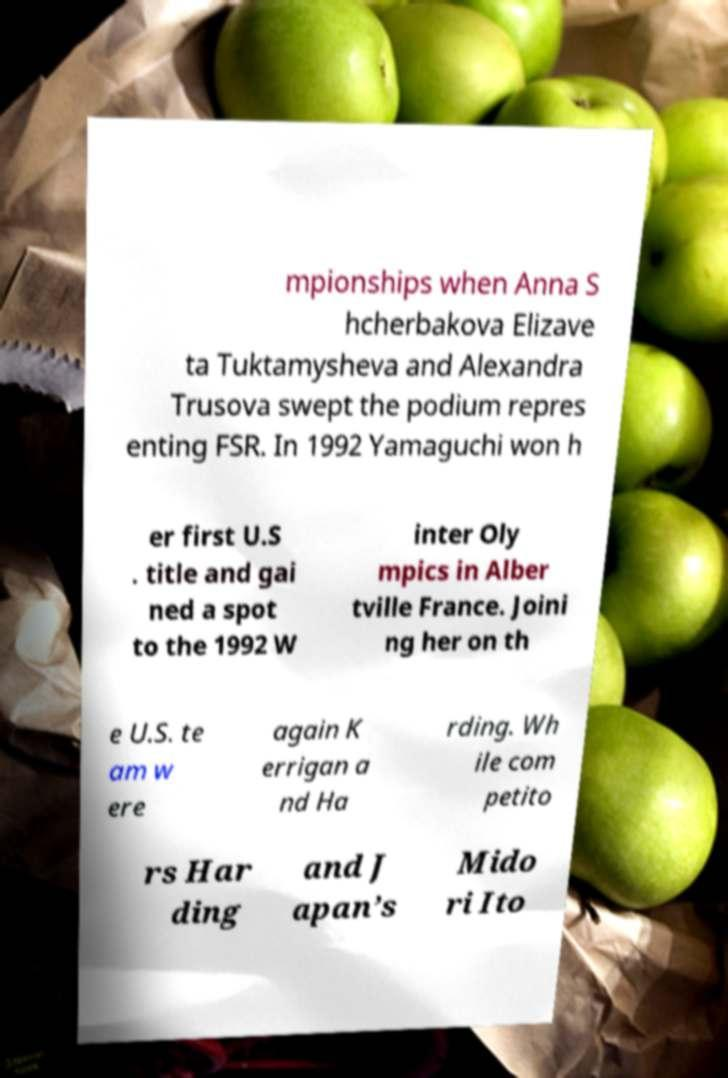For documentation purposes, I need the text within this image transcribed. Could you provide that? mpionships when Anna S hcherbakova Elizave ta Tuktamysheva and Alexandra Trusova swept the podium repres enting FSR. In 1992 Yamaguchi won h er first U.S . title and gai ned a spot to the 1992 W inter Oly mpics in Alber tville France. Joini ng her on th e U.S. te am w ere again K errigan a nd Ha rding. Wh ile com petito rs Har ding and J apan’s Mido ri Ito 